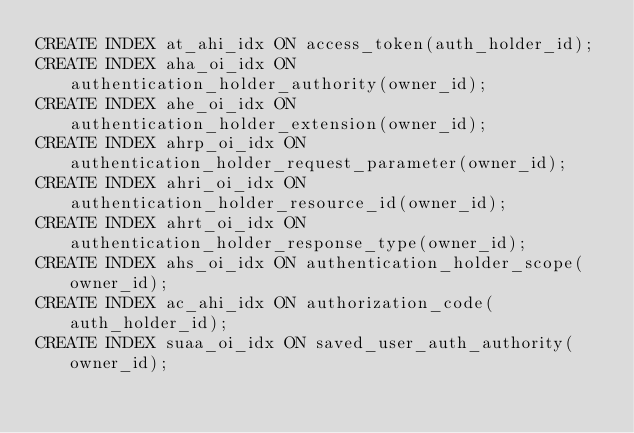Convert code to text. <code><loc_0><loc_0><loc_500><loc_500><_SQL_>CREATE INDEX at_ahi_idx ON access_token(auth_holder_id);
CREATE INDEX aha_oi_idx ON authentication_holder_authority(owner_id);
CREATE INDEX ahe_oi_idx ON authentication_holder_extension(owner_id);
CREATE INDEX ahrp_oi_idx ON authentication_holder_request_parameter(owner_id);
CREATE INDEX ahri_oi_idx ON authentication_holder_resource_id(owner_id);
CREATE INDEX ahrt_oi_idx ON authentication_holder_response_type(owner_id);
CREATE INDEX ahs_oi_idx ON authentication_holder_scope(owner_id);
CREATE INDEX ac_ahi_idx ON authorization_code(auth_holder_id);
CREATE INDEX suaa_oi_idx ON saved_user_auth_authority(owner_id);
</code> 